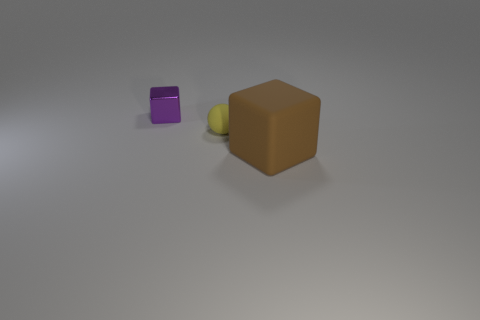Is there anything else that has the same shape as the yellow thing?
Your response must be concise. No. Is there anything else that is the same size as the brown matte object?
Ensure brevity in your answer.  No. Is there a matte object of the same shape as the small purple metal thing?
Offer a terse response. Yes. What number of rubber things are the same shape as the small metallic thing?
Make the answer very short. 1. Are there fewer small yellow spheres than tiny things?
Ensure brevity in your answer.  Yes. There is a cube that is right of the tiny metallic cube; what is it made of?
Make the answer very short. Rubber. What is the material of the yellow thing that is the same size as the purple metallic object?
Your response must be concise. Rubber. What is the material of the block that is to the left of the cube that is to the right of the block behind the brown rubber object?
Ensure brevity in your answer.  Metal. Does the block that is to the right of the yellow thing have the same size as the purple metallic thing?
Keep it short and to the point. No. Are there more tiny things than big blue metal spheres?
Your answer should be compact. Yes. 